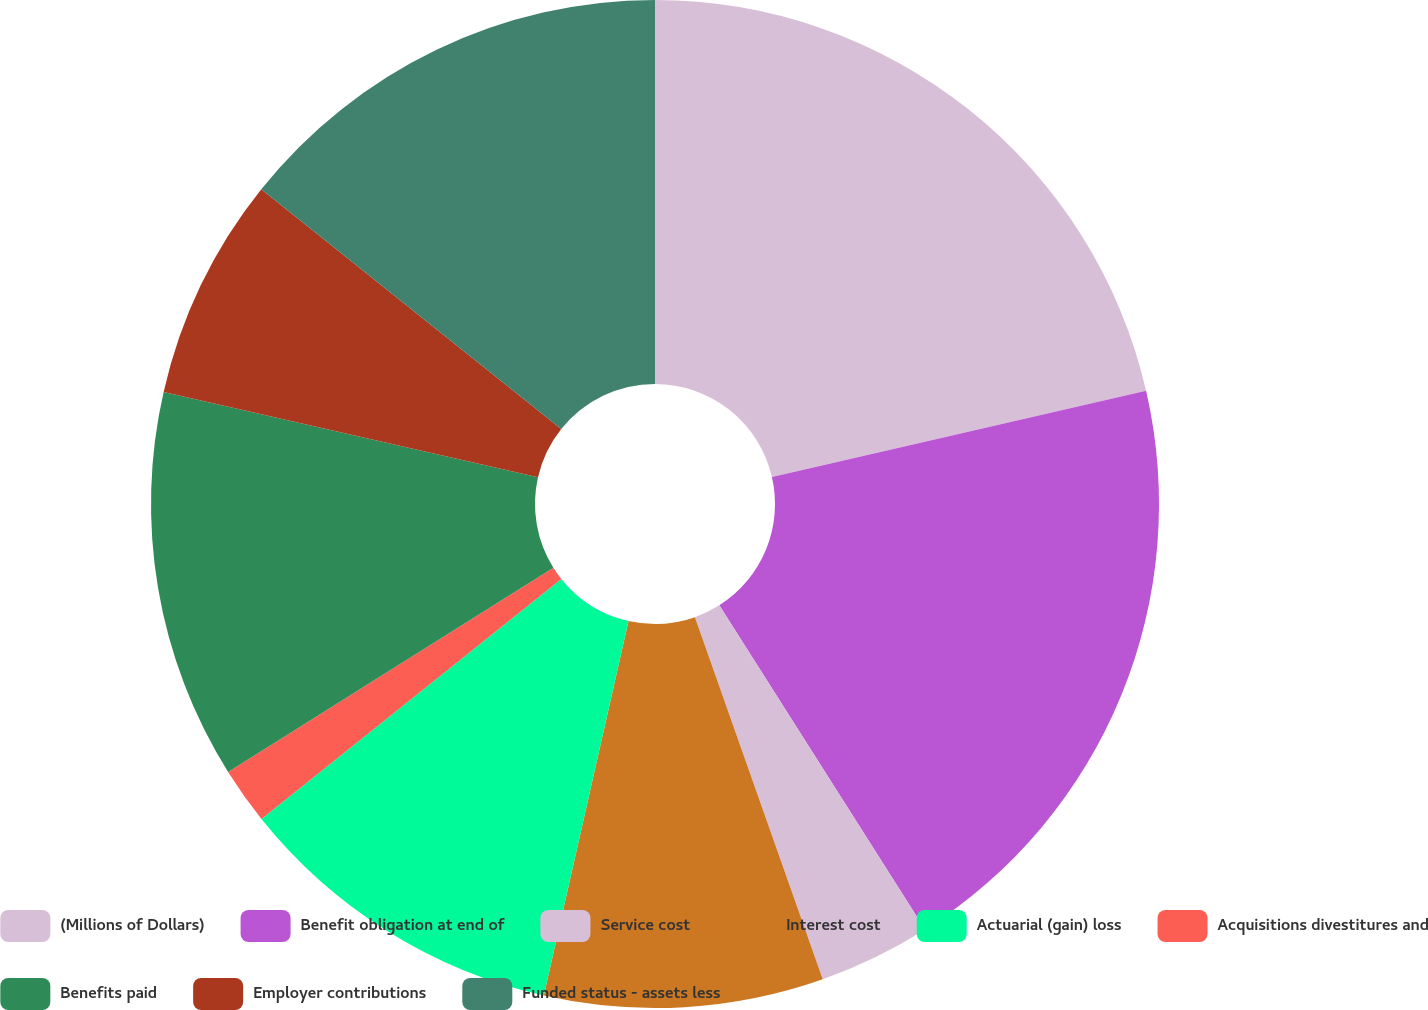Convert chart to OTSL. <chart><loc_0><loc_0><loc_500><loc_500><pie_chart><fcel>(Millions of Dollars)<fcel>Benefit obligation at end of<fcel>Service cost<fcel>Interest cost<fcel>Actuarial (gain) loss<fcel>Acquisitions divestitures and<fcel>Benefits paid<fcel>Employer contributions<fcel>Funded status - assets less<nl><fcel>21.39%<fcel>19.61%<fcel>3.6%<fcel>8.94%<fcel>10.72%<fcel>1.82%<fcel>12.49%<fcel>7.16%<fcel>14.27%<nl></chart> 